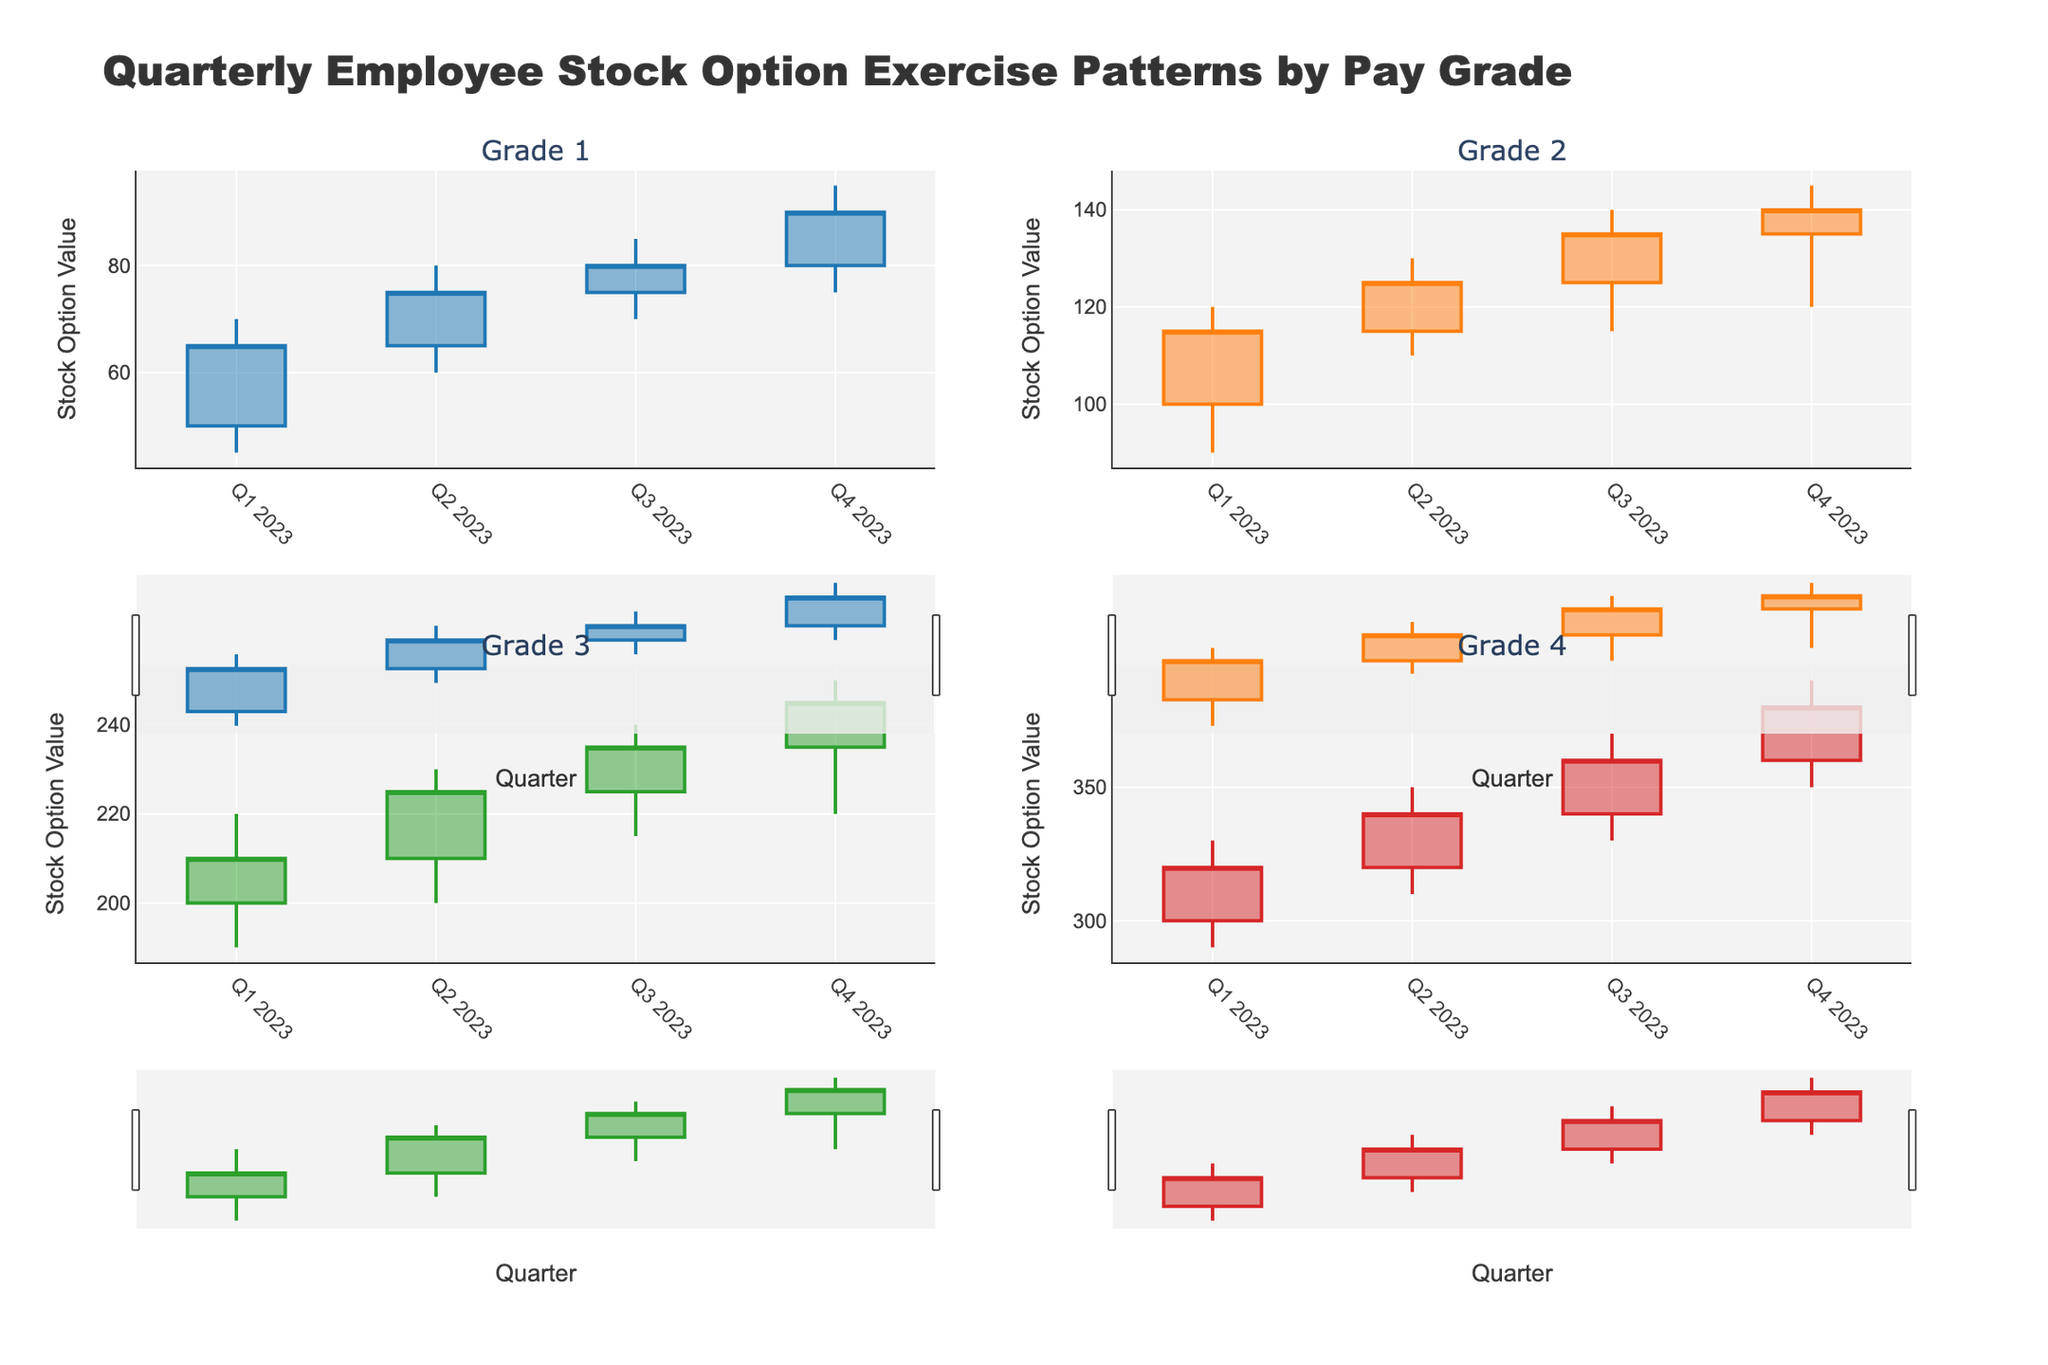What is the title of the figure? The title of the figure is displayed at the top and is meant to give an overview of the data being visualized. Here, it describes quarterly employee stock option exercise patterns categorized by pay grade.
Answer: Quarterly Employee Stock Option Exercise Patterns by Pay Grade For Grade 1 in Q2 2023, what are the opening and closing values? For each grade and quarter, the opening and closing values are shown as part of the candlestick for that period. The opening value is the bottom of the candlestick body, while the closing value is the top. For Grade 1 in Q2 2023, these values are 65 and 75, respectively.
Answer: Open: 65, Close: 75 Which pay grade shows the highest closing value in Q4 2023? To find this, we look at the closing values for each pay grade in Q4 2023. Grade 4 has the highest closing value since it reaches 380.
Answer: Grade 4 Between Grades 2 and 3, which one experienced a higher average increase in stock option values from Q1 to Q4 2023? First, calculate the increase for each grade from Q1 to Q4. For Grade 2: Close in Q4 is 140, Close in Q1 is 115, so the increase is 25. For Grade 3: Close in Q4 is 245, Close in Q1 is 210, so the increase is 35. Then, average these increases (25 for Grade 2 and 35 for Grade 3). Grade 3 has a higher average increase.
Answer: Grade 3 Which quarter shows the most significant decrease in stock option values for Grade 1? By examining the candlestick representations for Grade 1, we notice that the only decrease occurs between Q3 2023 and Q4 2023, where the opening value (80) is higher than the closing value (90). Therefore, there isn't a quarter with a decrease.
Answer: None Is there any pay grade that shows consistently increasing closing values every quarter? By observing the candlestick plots, we can see that for Grade 2, the closing values increase in every quarter from Q1 2023 to Q4 2023: 115, 125, 135, and 140, respectively.
Answer: Grade 2 What is the range (difference between high and low values) for Grade 3 in Q3 2023? To find the range, subtract the lowest value from the highest value for Grade 3 in Q3 2023. The high is 240, and the low is 215, so the range is 240 - 215 = 25.
Answer: 25 